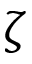<formula> <loc_0><loc_0><loc_500><loc_500>\zeta</formula> 